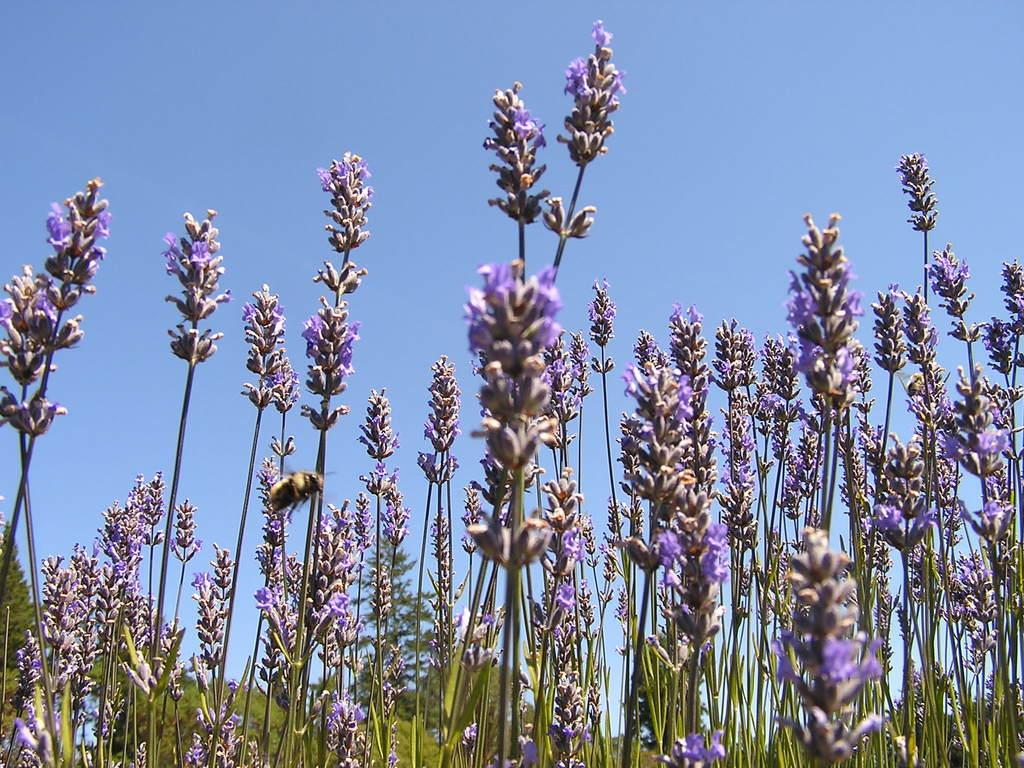What type of living organisms can be seen in the image? There are flowers, plants, and an insect visible in the image. What parts of the plants can be seen in the image? There are stems in the image. What is visible in the background of the image? Trees and the sky are visible in the background of the image. Can you tell me how many eggs are on the rail in the image? There are no eggs or rails present in the image. Is there a bike visible in the image? There is no bike present in the image. 